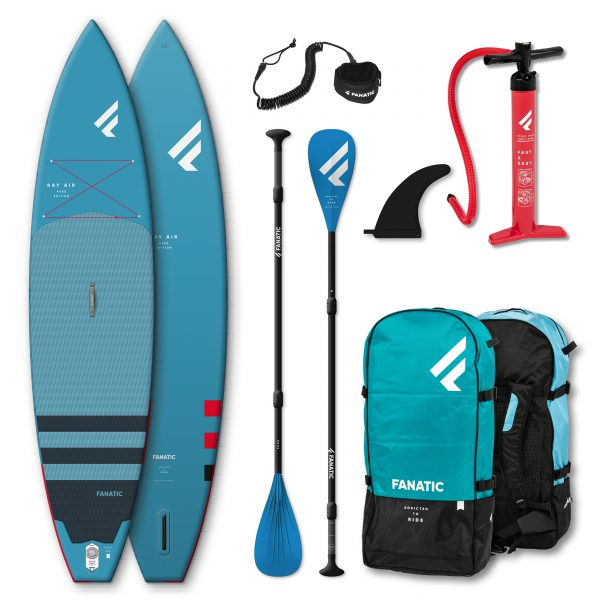Can you list all the visible items that come with the stand-up paddleboards in the image? Certainly! The image shows the following items: two stand-up paddleboards, two adjustable paddles, a coiled leash, a large fin, a manual pump, and two carrying backpacks. 